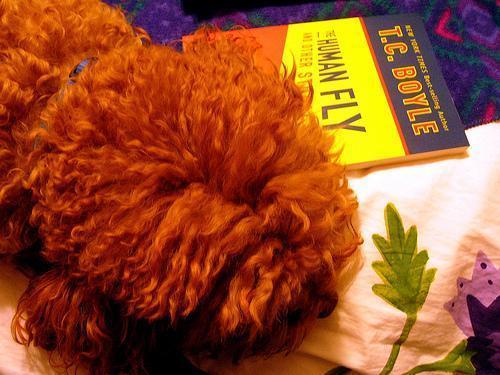How many books are there?
Give a very brief answer. 1. 